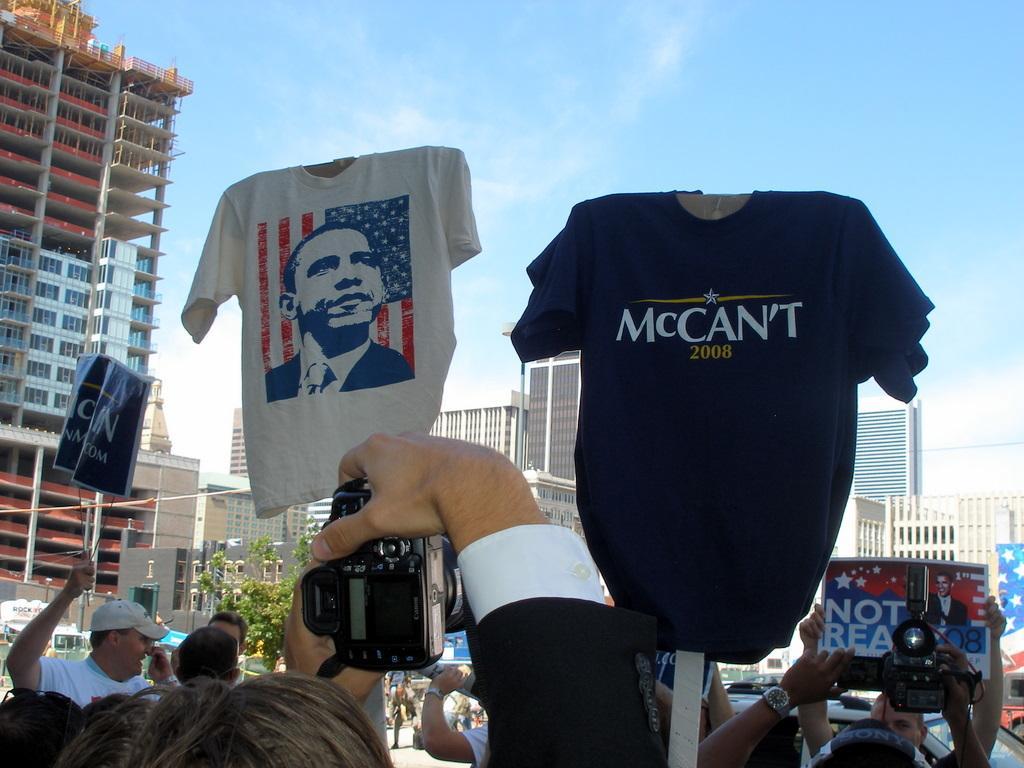How would you summarize this image in a sentence or two? In this image two shirts are displayed. At the top of the image there is a sky with clouds. In the left side of the image there is a building with windows and pillars. In the middle of the image a man holding a camera in his hand is standing. In the right side of the image there are few buildings and few people are holding a poster. 